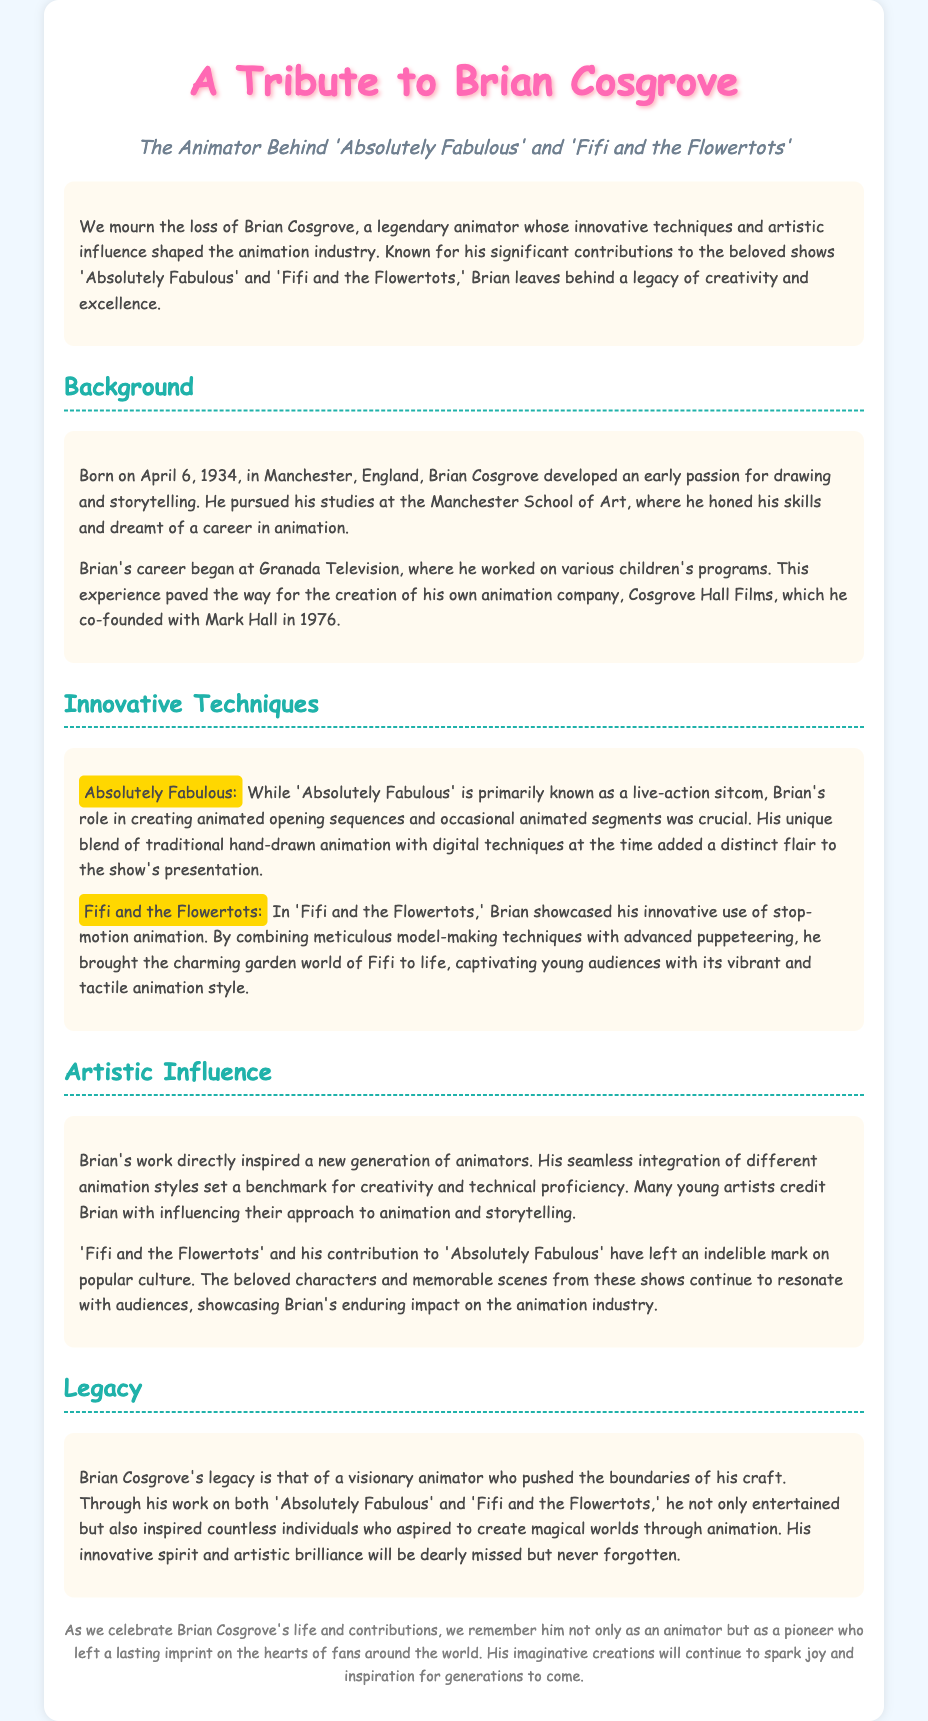What was Brian Cosgrove's birth date? The document states that Brian Cosgrove was born on April 6, 1934.
Answer: April 6, 1934 Which animation company did Brian co-found? The document mentions that Brian co-founded Cosgrove Hall Films.
Answer: Cosgrove Hall Films What technique did Brian use in 'Fifi and the Flowertots'? According to the document, Brian showcased his innovative use of stop-motion animation in 'Fifi and the Flowertots.'
Answer: Stop-motion animation What impact did Brian Cosgrove have on young animators? The document states that many young artists credit Brian with influencing their approach to animation and storytelling.
Answer: Influence on young animators What is described as Brian's legacy? The document refers to Brian's legacy as that of a visionary animator who pushed the boundaries of his craft.
Answer: Visionary animator How did Brian's work influence popular culture? The document mentions that 'Fifi and the Flowertots' and his contribution to 'Absolutely Fabulous' have left an indelible mark on popular culture.
Answer: Indelible mark on popular culture What characterizes the animation style of 'Absolutely Fabulous'? The document indicates that Brian's unique blend of traditional hand-drawn animation with digital techniques added a distinct flair to 'Absolutely Fabulous.'
Answer: Distinct flair Where did Brian Cosgrove study? The document notes that Brian pursued his studies at the Manchester School of Art.
Answer: Manchester School of Art 